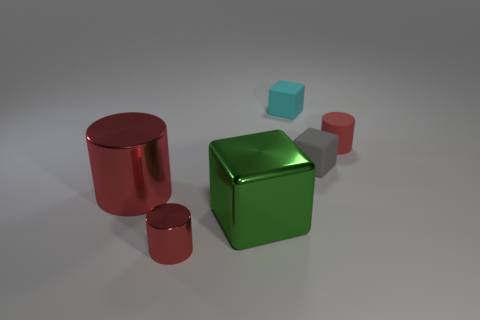There is a small cylinder that is the same color as the small metal thing; what material is it?
Your answer should be very brief. Rubber. What material is the cube that is the same size as the cyan rubber thing?
Provide a succinct answer. Rubber. What number of tiny cyan things are there?
Make the answer very short. 1. What number of things are red cylinders or small red things behind the gray block?
Your answer should be compact. 3. Does the thing on the right side of the gray cube have the same size as the tiny red shiny cylinder?
Provide a short and direct response. Yes. How many rubber things are either gray things or cyan cubes?
Your answer should be compact. 2. What is the size of the red shiny thing in front of the green metal block?
Offer a very short reply. Small. Do the green thing and the tiny cyan object have the same shape?
Offer a very short reply. Yes. How many tiny objects are either brown metallic spheres or cyan rubber things?
Give a very brief answer. 1. Are there any red rubber objects on the right side of the small red metallic object?
Give a very brief answer. Yes. 